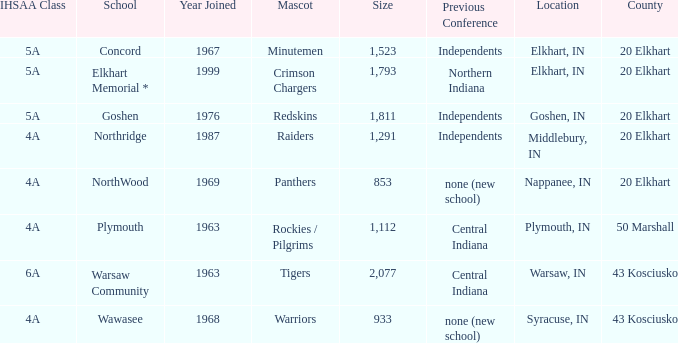What is the IHSAA class for the team located in Middlebury, IN? 4A. 